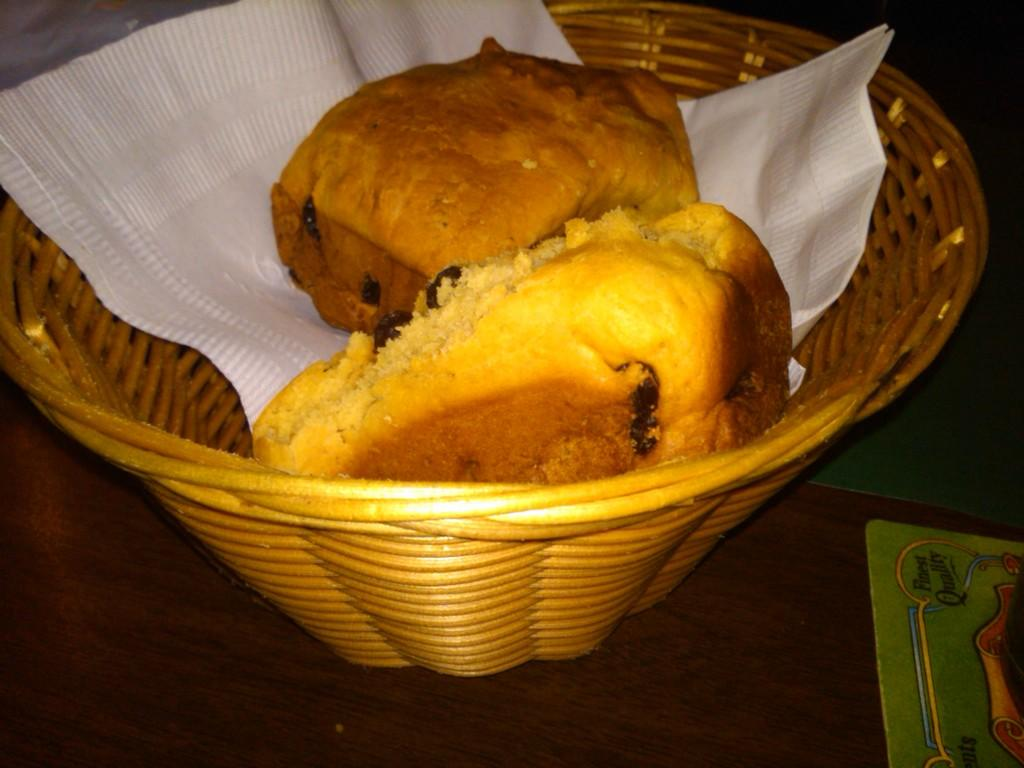What type of food item is in the basket in the image? There are buns in a basket in the image. Can you describe the color of the tissue in the image? The tissue in the image is white. Who is the owner of the buns in the image? There is no information about the ownership of the buns in the image. What month is depicted in the image? There is no indication of a specific month in the image. 